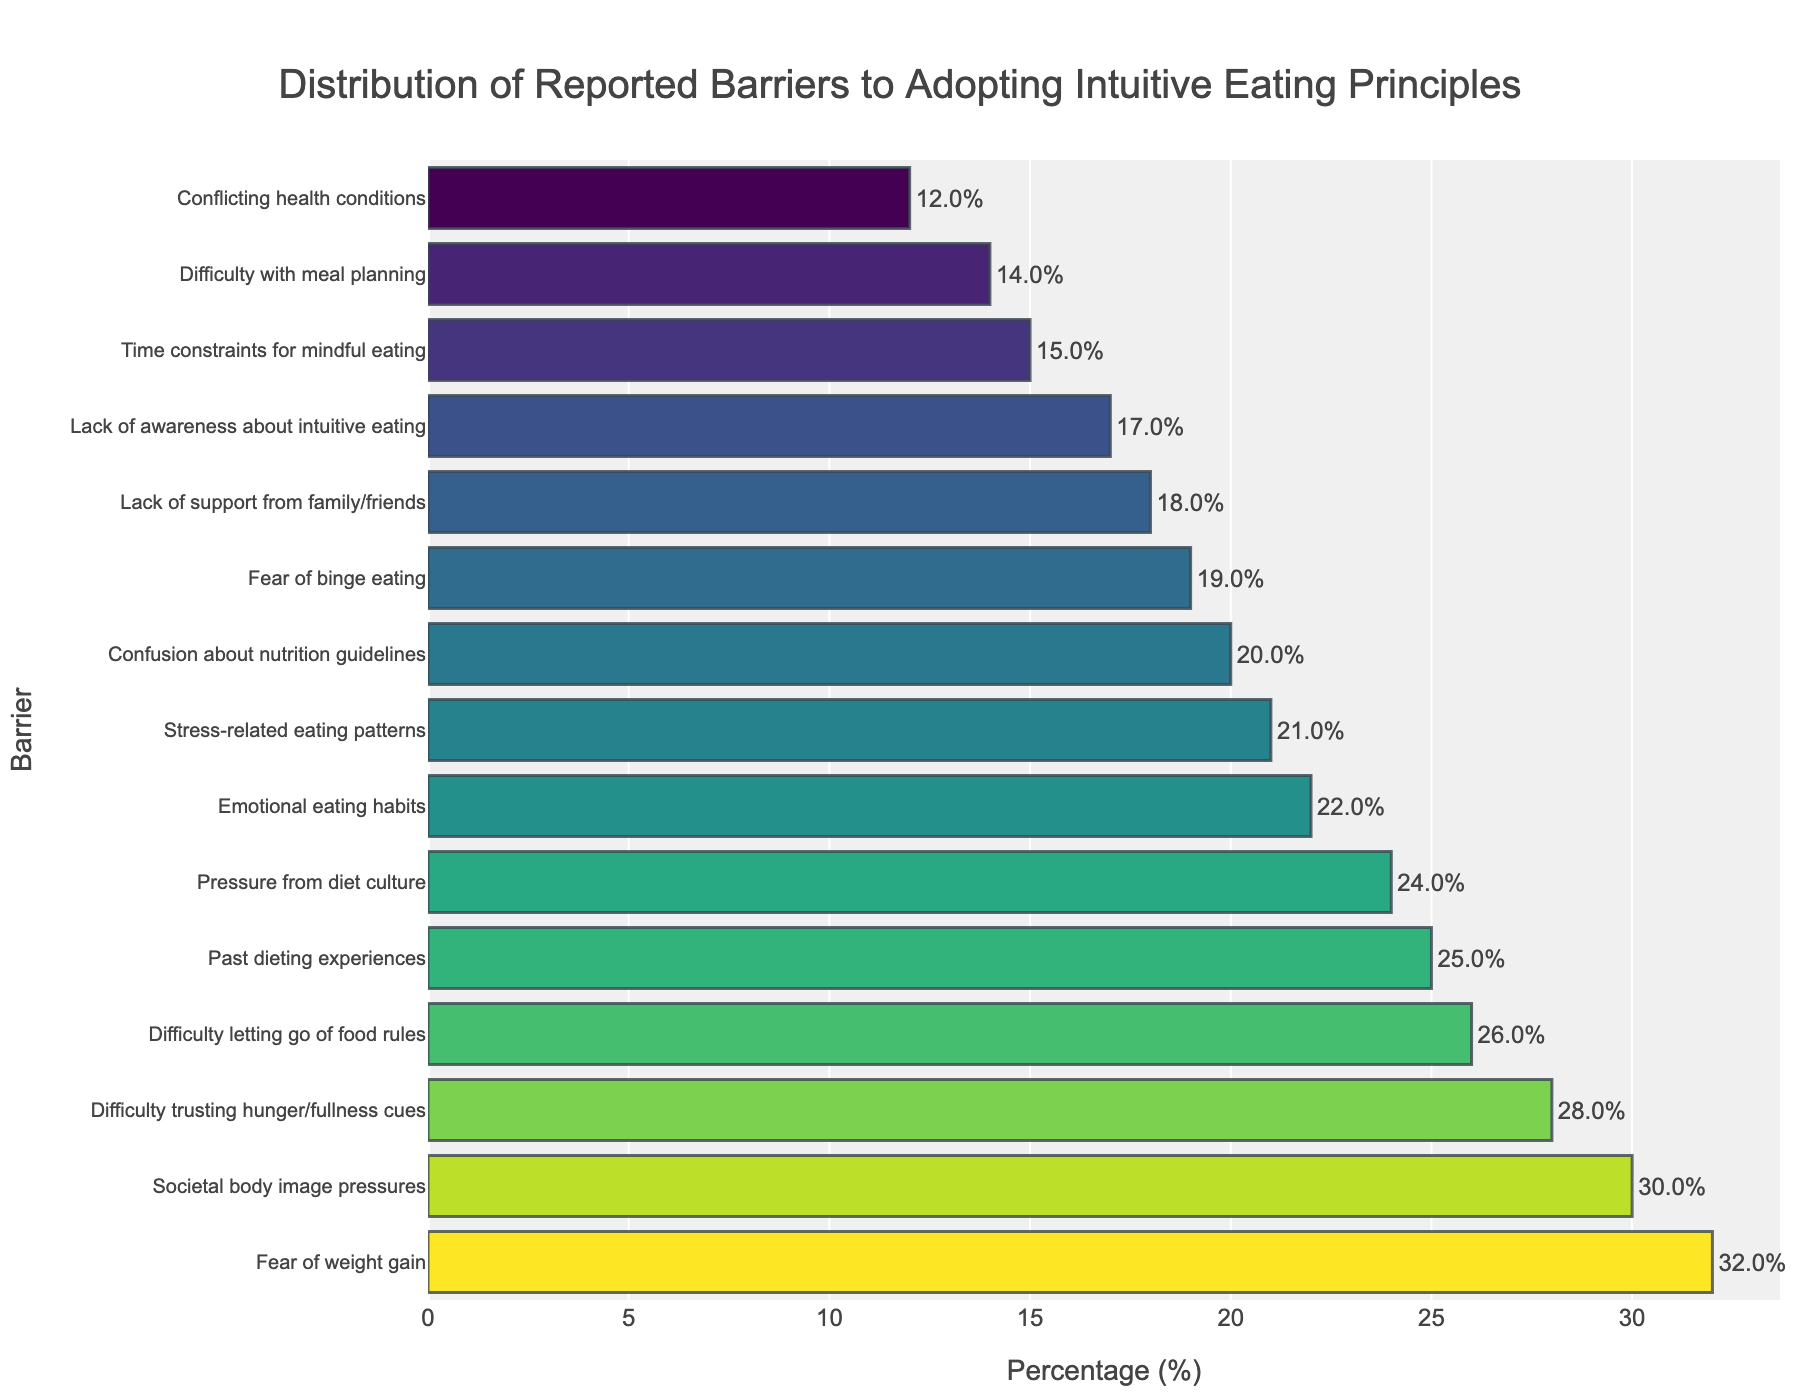What's the most common reported barrier to adopting intuitive eating principles? The bar with the highest percentage indicates the most common reported barrier, which is "Fear of weight gain" at 32%.
Answer: Fear of weight gain Which two barriers have the smallest percentages reported? By looking at the shortest bars, we can see that "Difficulty with meal planning" at 14% and "Conflicting health conditions" at 12% are the smallest percentages reported.
Answer: Difficulty with meal planning and Conflicting health conditions Compare the reported percentages for "Emotional eating habits" and "Confusion about nutrition guidelines". The percentages for "Emotional eating habits" is 22% and for "Confusion about nutrition guidelines" is 20%. Since 22 is greater than 20, "Emotional eating habits" has a higher reported percentage.
Answer: Emotional eating habits What is the total reported percentage of barriers related directly to societal pressures (Societal body image pressures and Pressure from diet culture)? The reported percentage for "Societal body image pressures" is 30% and for "Pressure from diet culture" is 24%. The total is 30% + 24% = 54%.
Answer: 54% Identify all barriers with reported percentages greater than 25%. The bars greater than 25% are "Fear of weight gain" (32%), "Difficulty trusting hunger/fullness cues" (28%), "Societal body image pressures" (30%), and "Difficulty letting go of food rules" (26%).
Answer: Fear of weight gain, Difficulty trusting hunger/fullness cues, Societal body image pressures, Difficulty letting go of food rules What's the combined reported percentage for barriers related to managing emotions (Emotional eating habits and Stress-related eating patterns)? The reported percentage for "Emotional eating habits" is 22% and for "Stress-related eating patterns" is 21%. The combined is 22% + 21% = 43%.
Answer: 43% How does the height (or length) of the bar for "Lack of support from family/friends" compare to that of "Fear of binge eating"? "Lack of support from family/friends" has a reported percentage of 18%, whereas "Fear of binge eating" has 19%. Since 18 is less than 19, the bar for "Lack of support from family/friends" is shorter.
Answer: It is shorter Which barrier has the closest value to the median of all reported percentages? To find the median, we first need to list the percentages in ascending order: 12, 14, 15, 17, 18, 19, 20, 21, 22, 24, 25, 26, 28, 30, 32. The median (middle value) is the eighth value, which is 21. "Stress-related eating patterns" with 21% is the closest to this median.
Answer: Stress-related eating patterns What percentage difference is there between the highest and lowest reported barriers? The highest reported barrier is "Fear of weight gain" at 32%, and the lowest is "Conflicting health conditions" at 12%. The difference is 32% - 12% = 20%.
Answer: 20% 